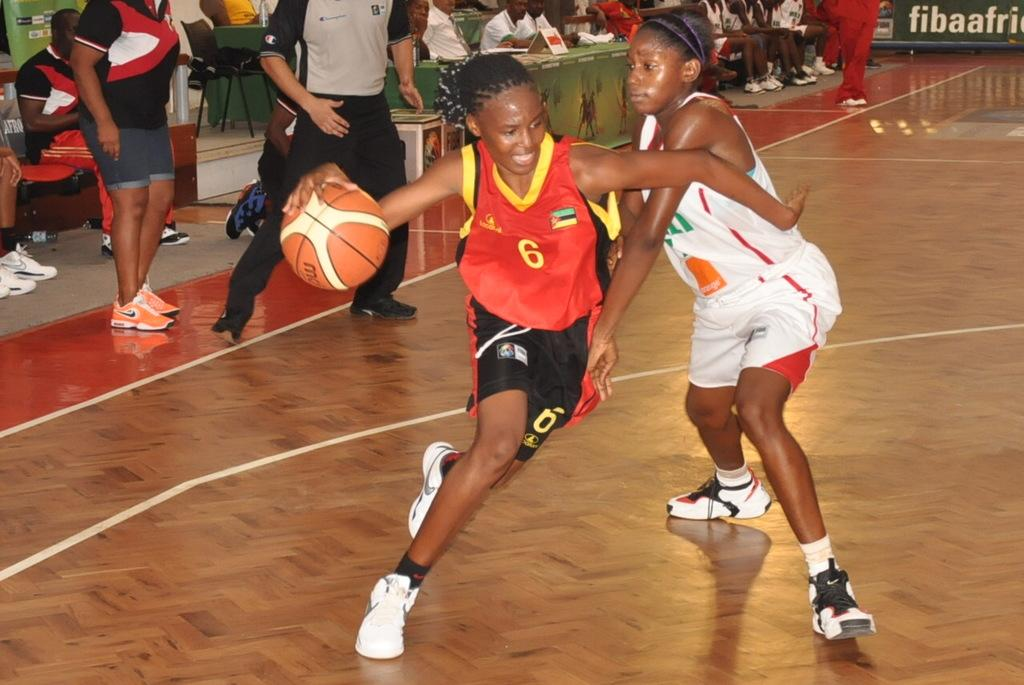<image>
Offer a succinct explanation of the picture presented. A young female basketball player wearing a red top with the number 6 on it scoots past her opponent. 